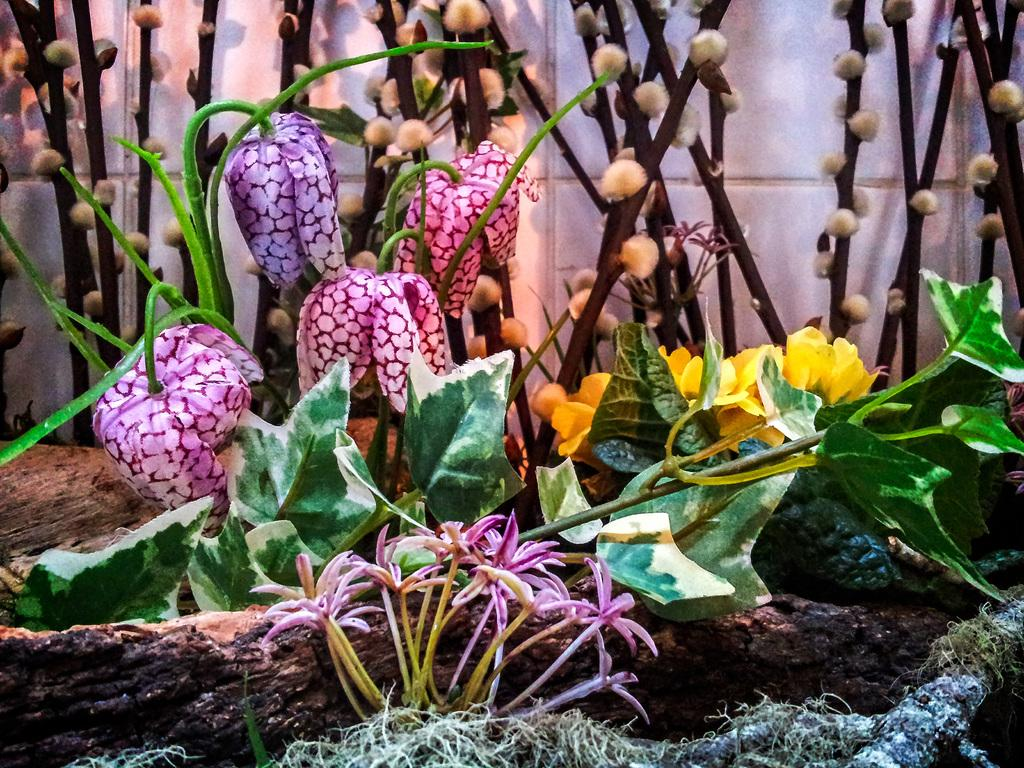What type of plants can be seen in the image? There are plants with flowers in the image. What part of a tree is visible in the image? Tree bark is visible in the image. What colors are present in the flowers? Some flowers are yellow in color, and some are purple in color. What is the background of the image? There is a wall in the image. What is the opinion of the laborer about the duck in the image? There is no laborer or duck present in the image, so it is not possible to determine their opinion. 